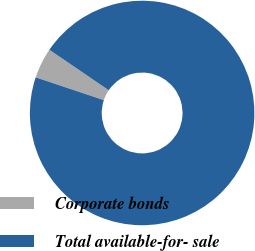Convert chart to OTSL. <chart><loc_0><loc_0><loc_500><loc_500><pie_chart><fcel>Corporate bonds<fcel>Total available-for- sale<nl><fcel>4.38%<fcel>95.62%<nl></chart> 